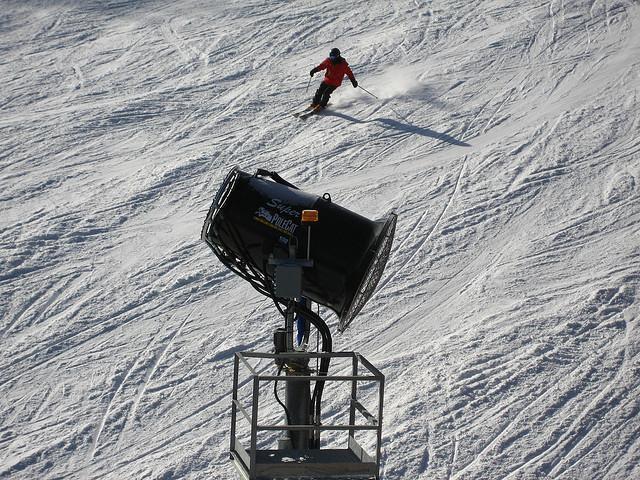What is the person in the jacket holding?
Pick the right solution, then justify: 'Answer: answer
Rationale: rationale.'
Options: Basket, kittens, eggs, skis. Answer: skis.
Rationale: The person is on a snowy mountain and is skiing. 